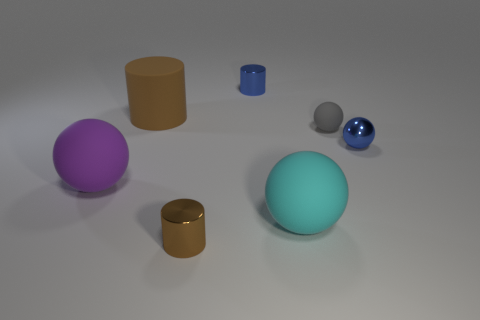Subtract all tiny cylinders. How many cylinders are left? 1 Subtract all cyan blocks. How many brown cylinders are left? 2 Subtract 1 cylinders. How many cylinders are left? 2 Subtract all blue spheres. How many spheres are left? 3 Add 2 cyan matte balls. How many objects exist? 9 Subtract all brown balls. Subtract all blue cylinders. How many balls are left? 4 Add 6 cylinders. How many cylinders are left? 9 Add 3 large matte cylinders. How many large matte cylinders exist? 4 Subtract 0 green balls. How many objects are left? 7 Subtract all balls. How many objects are left? 3 